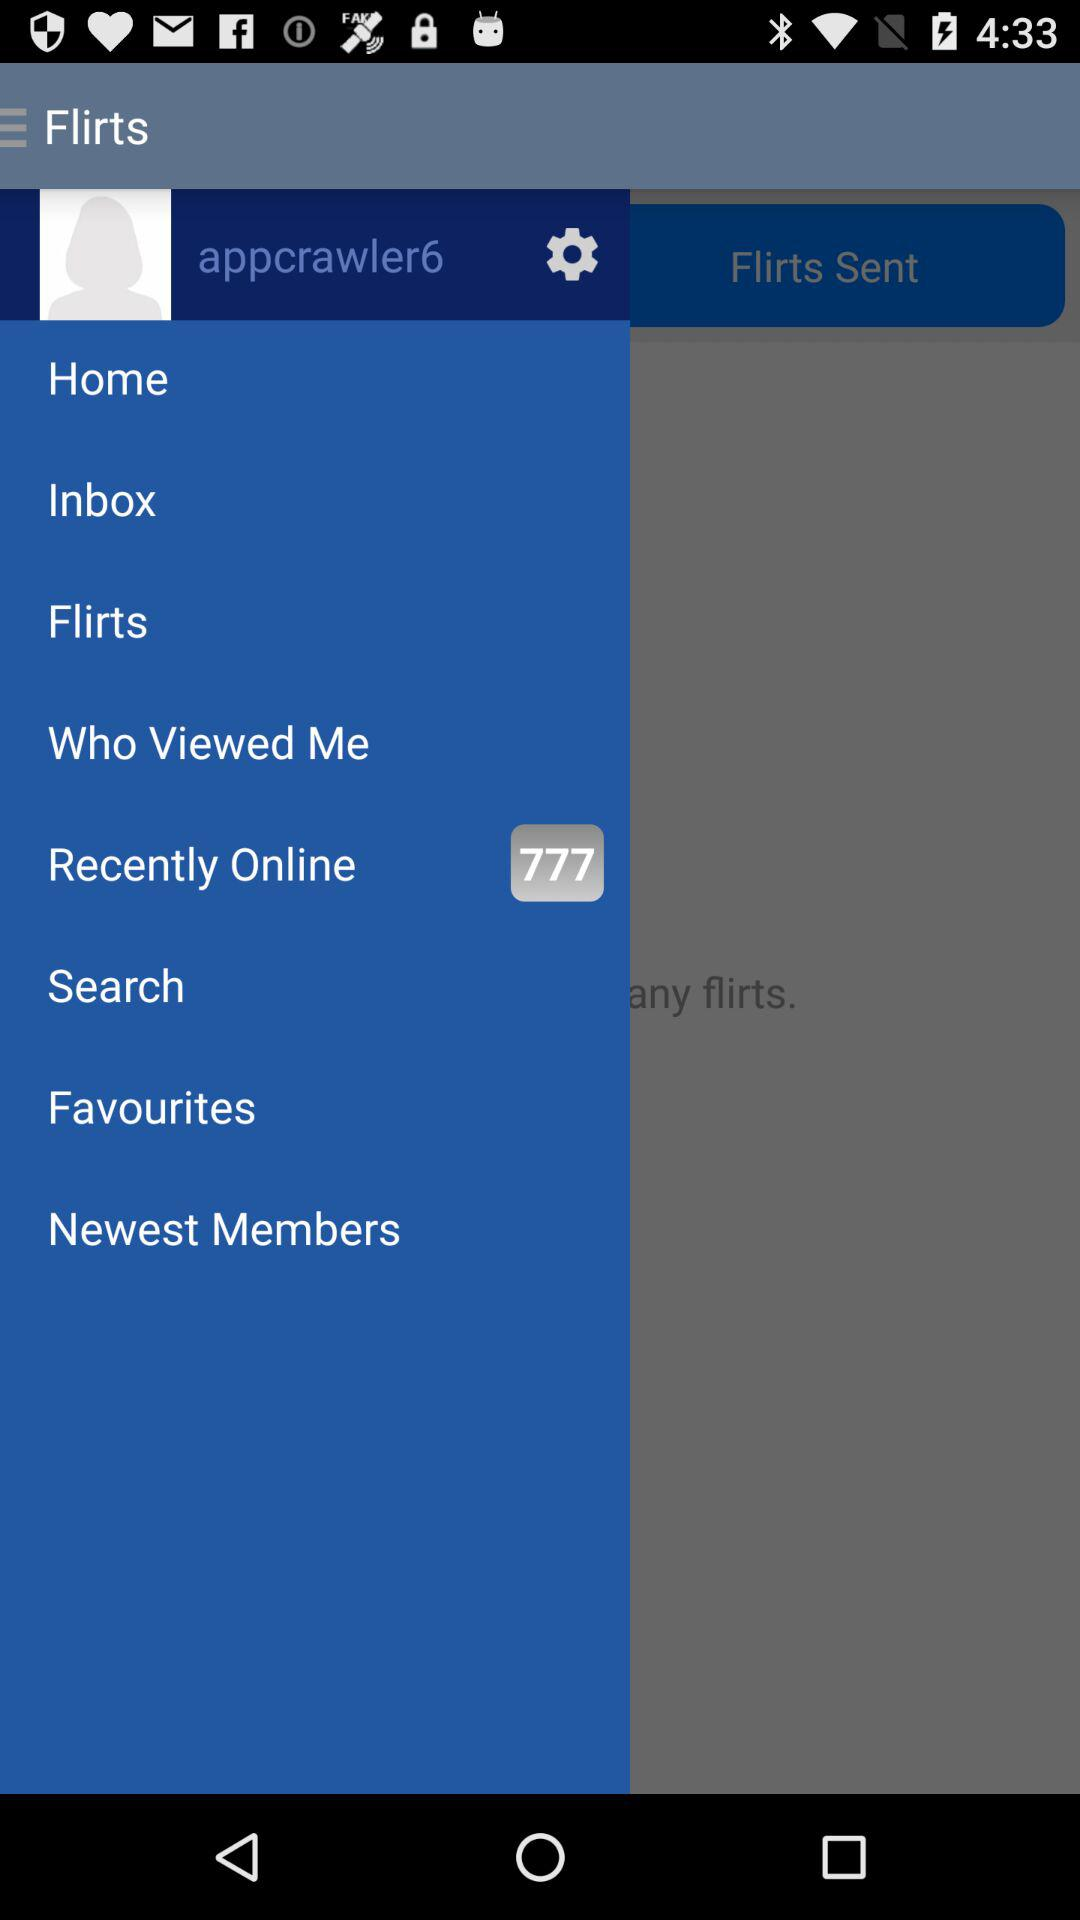What is the user name? The user name is appcrawler6. 